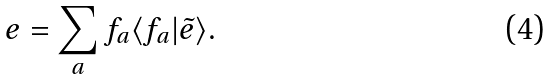<formula> <loc_0><loc_0><loc_500><loc_500>e = \sum _ { a } f _ { a } \langle f _ { a } | \tilde { e } \rangle .</formula> 